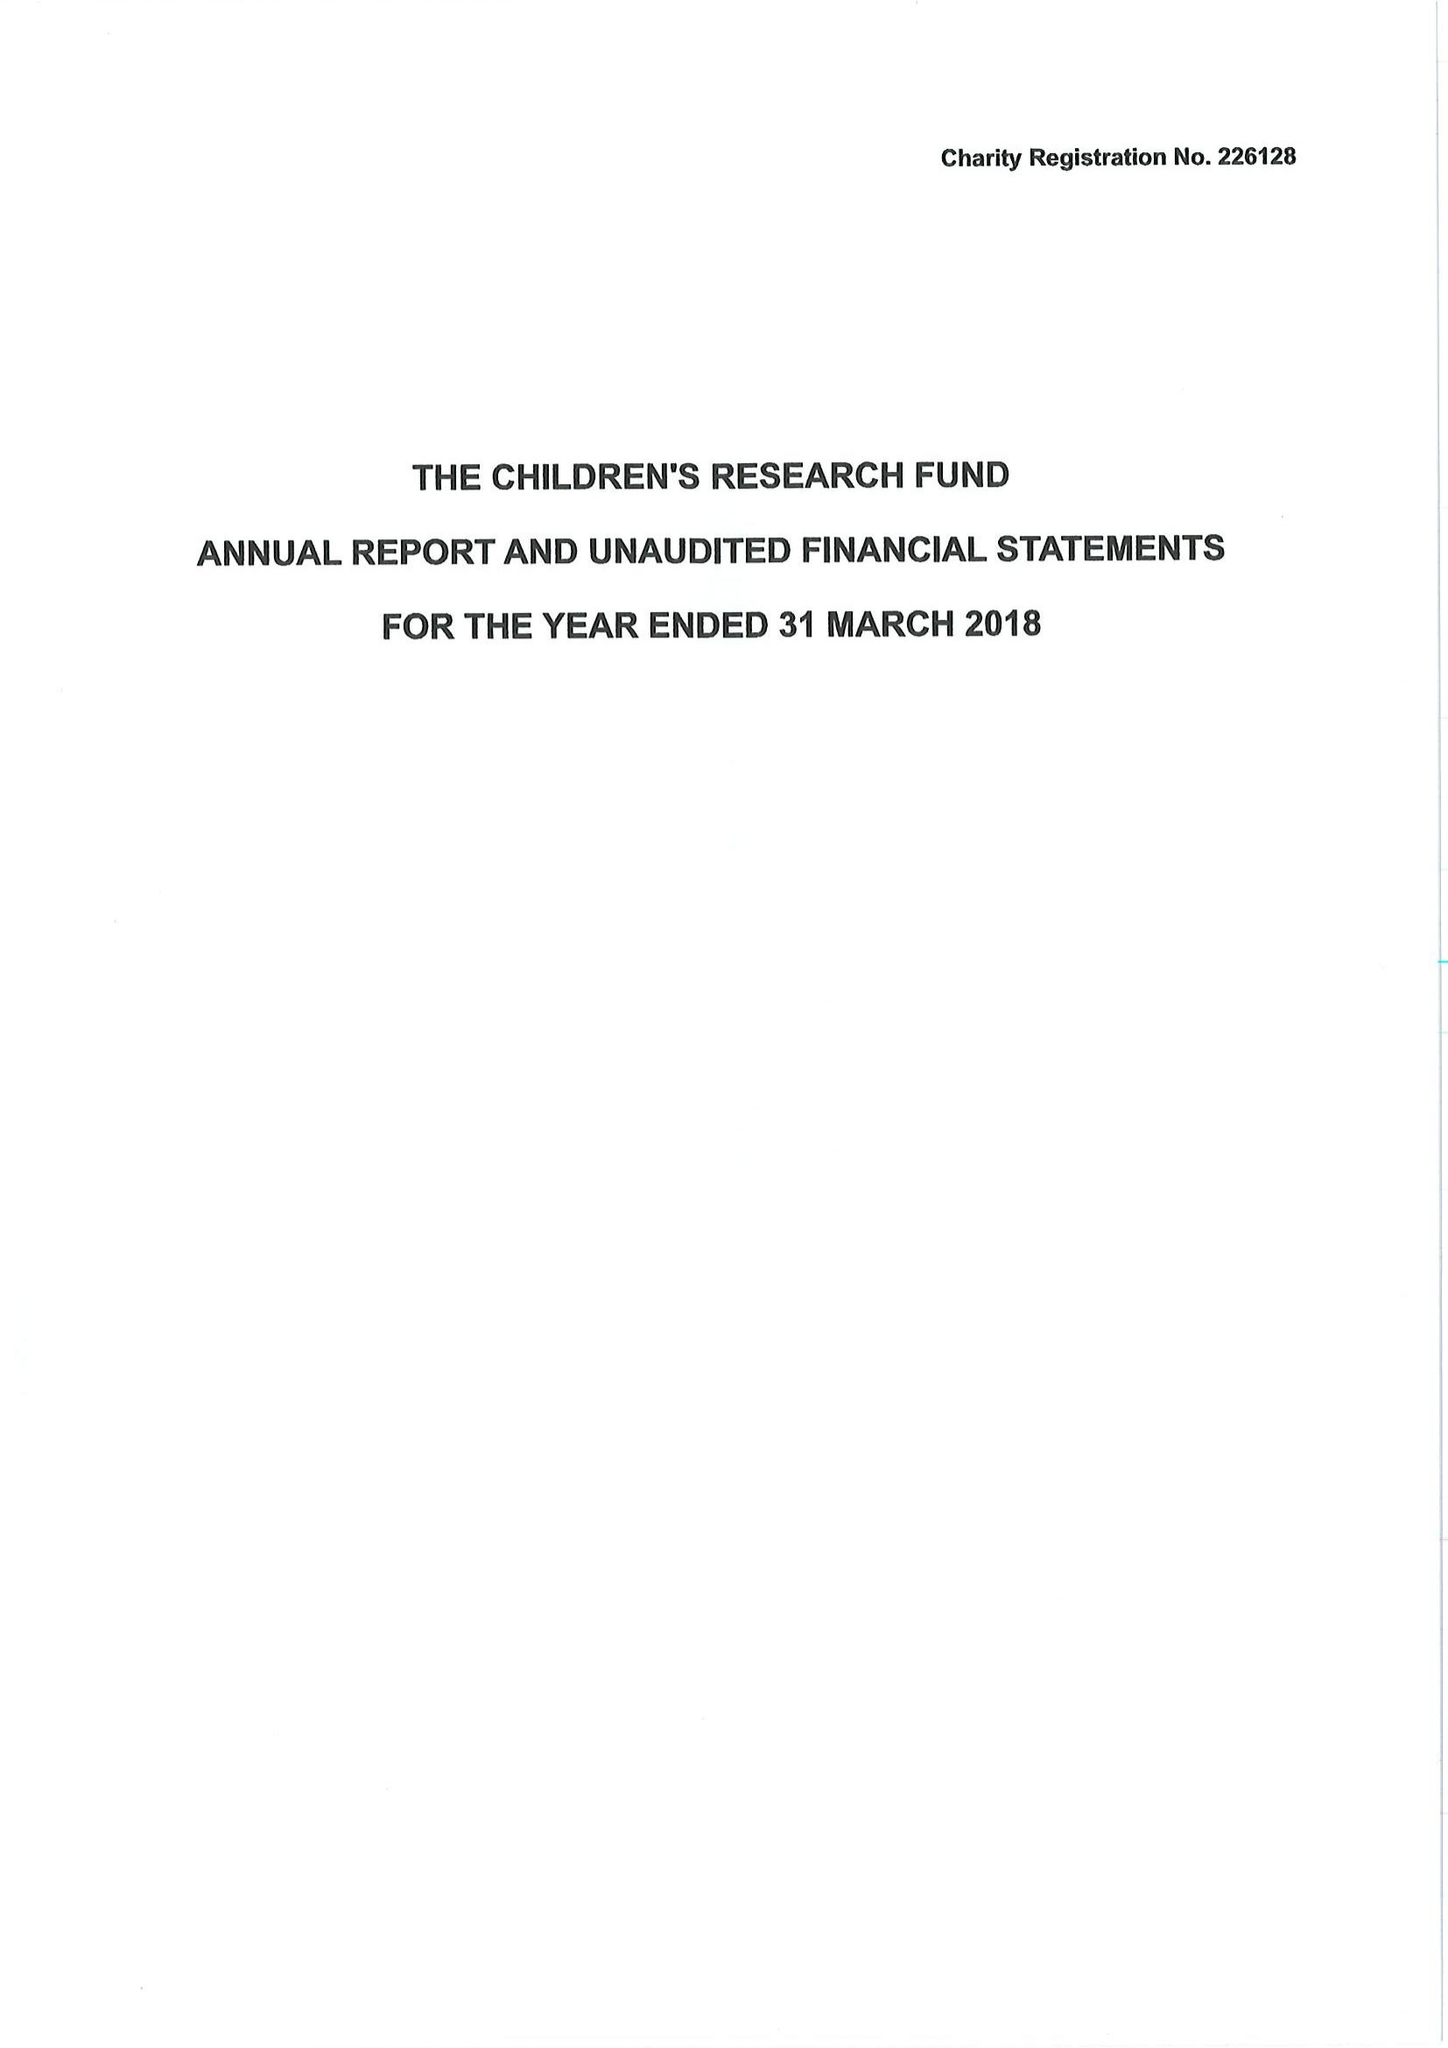What is the value for the charity_name?
Answer the question using a single word or phrase. The Children's Research Fund 